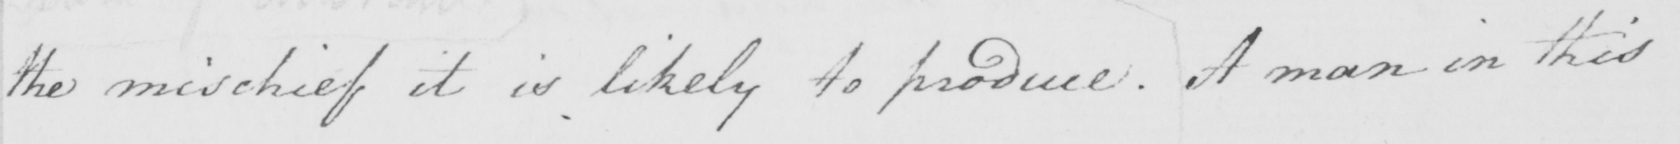Please transcribe the handwritten text in this image. the mischief it is likely to produce . A man in this 